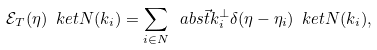Convert formula to latex. <formula><loc_0><loc_0><loc_500><loc_500>\mathcal { E } _ { T } ( \eta ) \ k e t { N ( k _ { i } ) } = \sum _ { i \in N } \ a b s { \vec { t } { k } _ { i } ^ { \perp } } \delta ( \eta - \eta _ { i } ) \ k e t { N ( k _ { i } ) } ,</formula> 